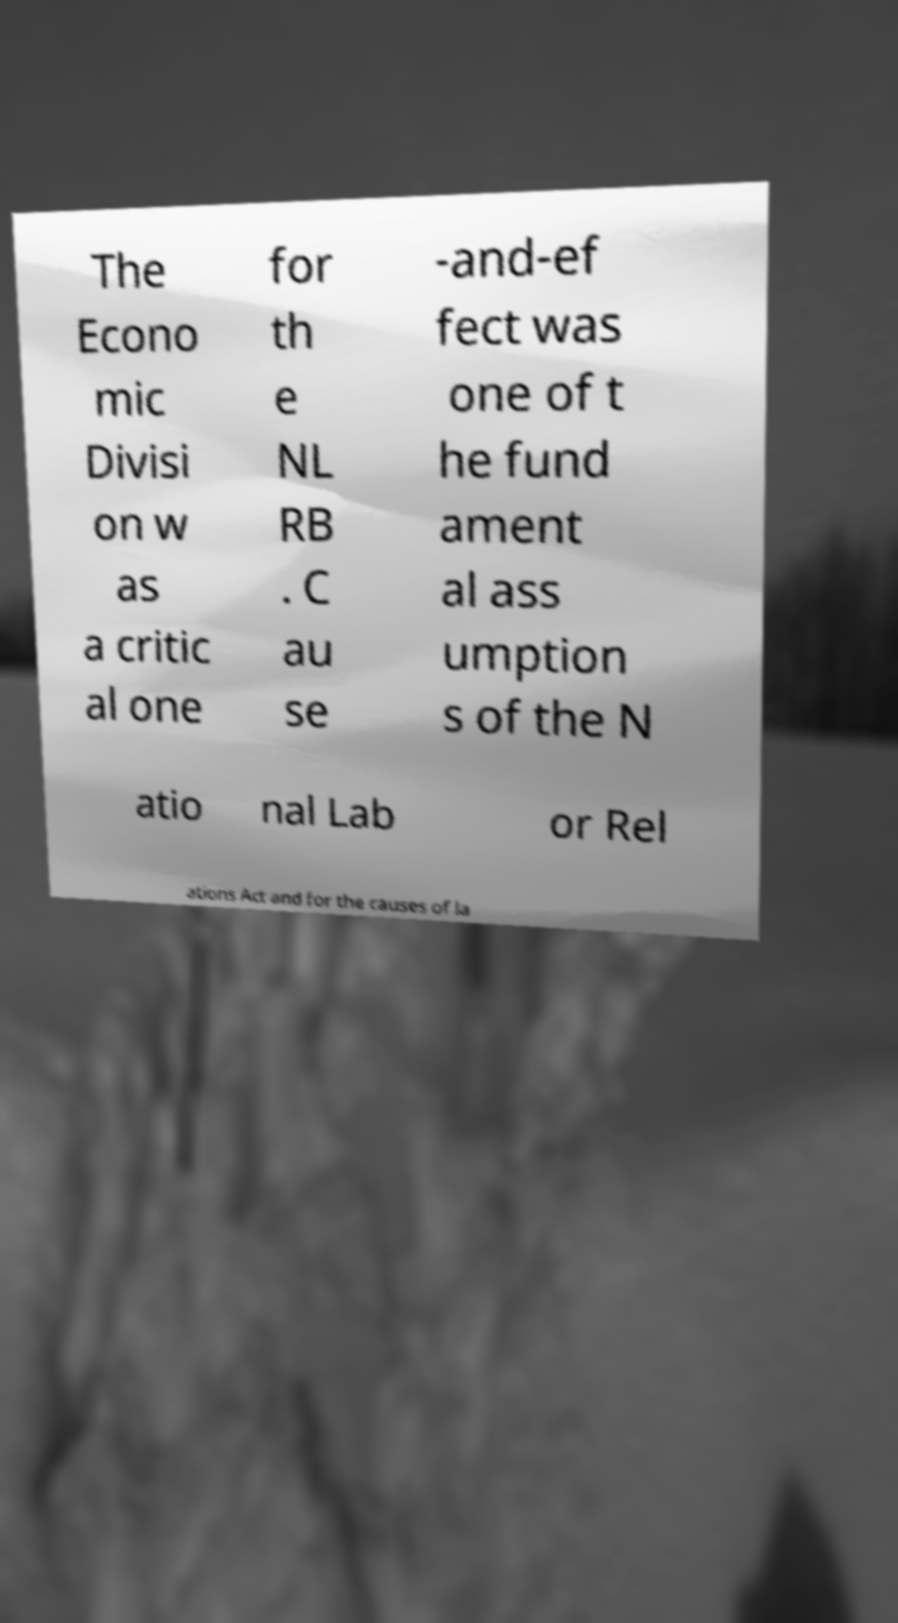There's text embedded in this image that I need extracted. Can you transcribe it verbatim? The Econo mic Divisi on w as a critic al one for th e NL RB . C au se -and-ef fect was one of t he fund ament al ass umption s of the N atio nal Lab or Rel ations Act and for the causes of la 